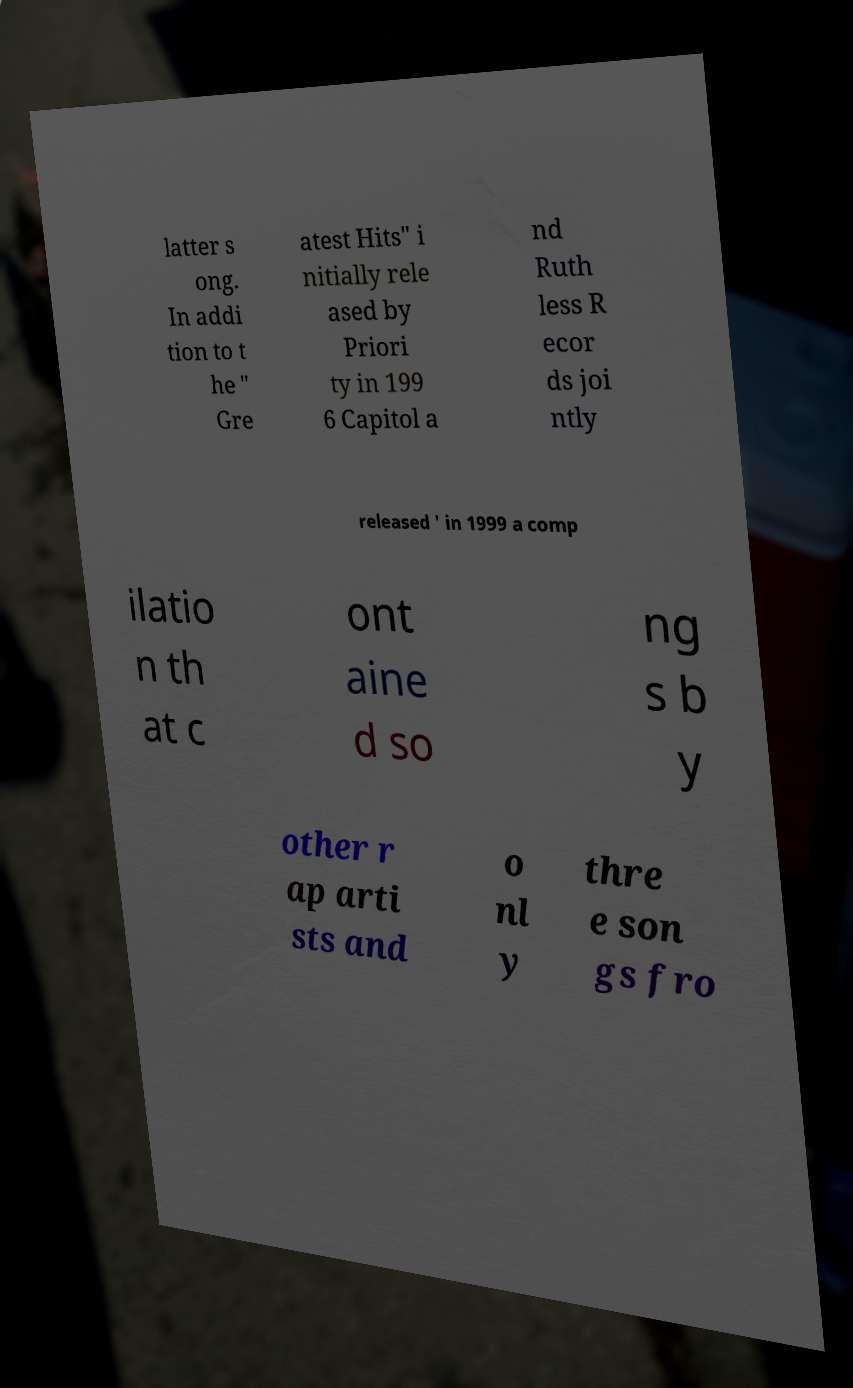There's text embedded in this image that I need extracted. Can you transcribe it verbatim? latter s ong. In addi tion to t he " Gre atest Hits" i nitially rele ased by Priori ty in 199 6 Capitol a nd Ruth less R ecor ds joi ntly released ' in 1999 a comp ilatio n th at c ont aine d so ng s b y other r ap arti sts and o nl y thre e son gs fro 